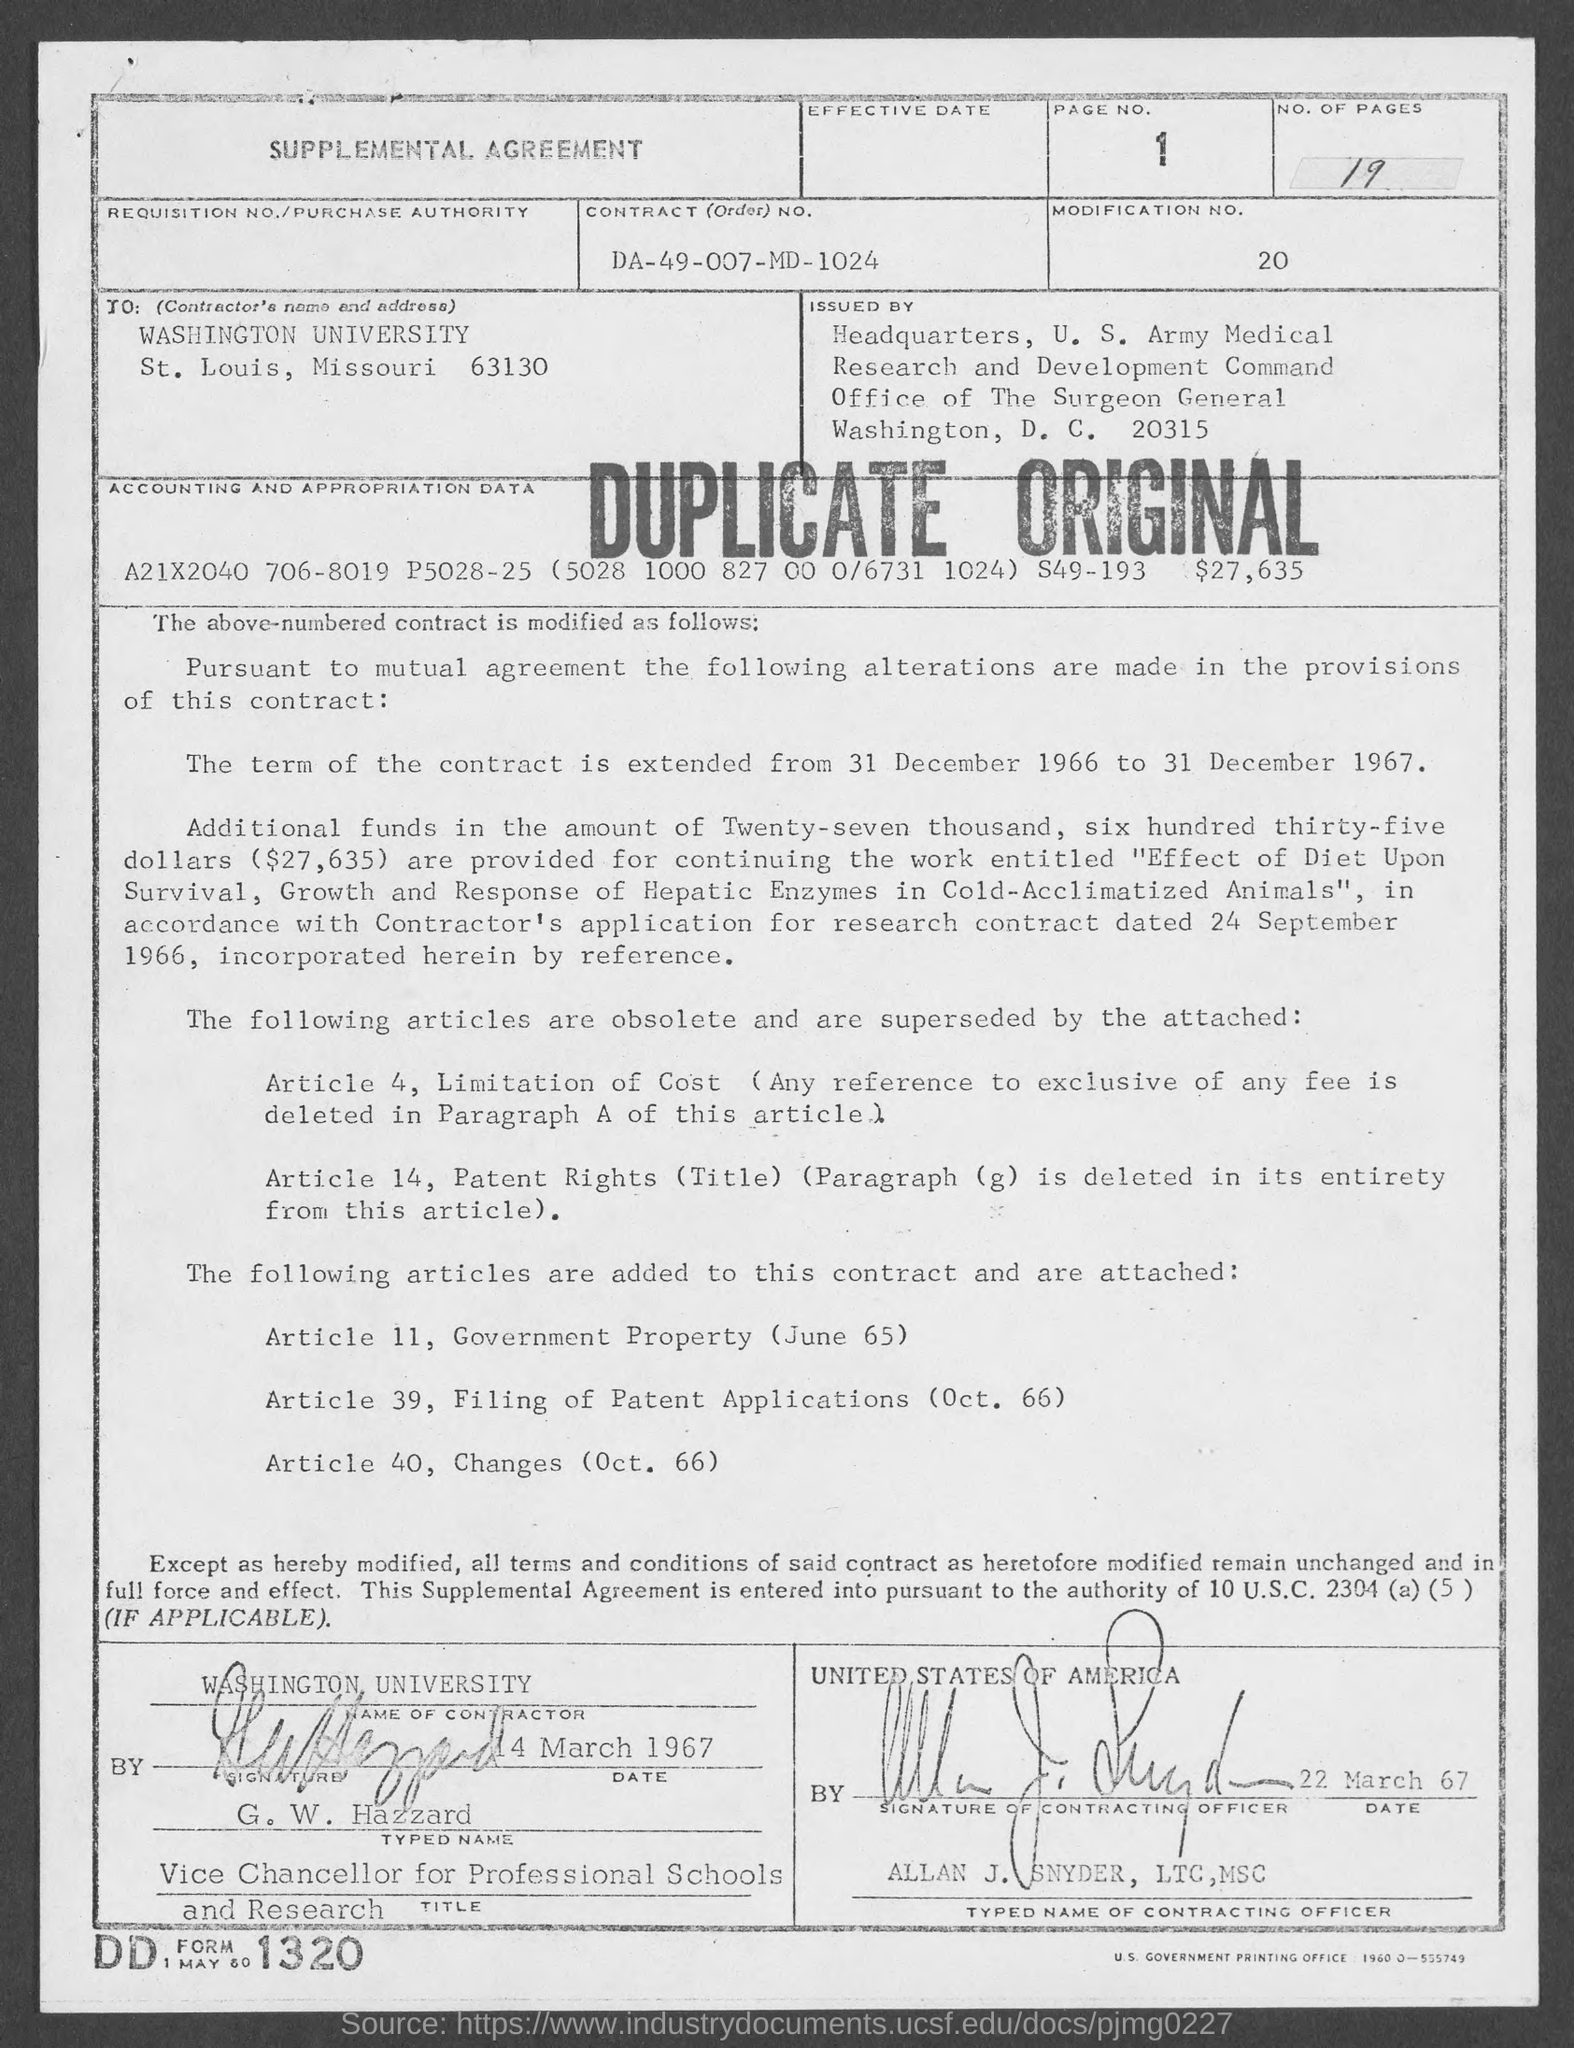Indicate a few pertinent items in this graphic. The university mentioned in the given agreement is Washington University. Can you please provide the page number mentioned in the agreement? The contract number mentioned in the given agreement is DA-49-007-MD-1024. The modification number mentioned in the given agreement is 20.. The signature of the contracting officer is named Allan J. Snyder, LTC, MSC. 